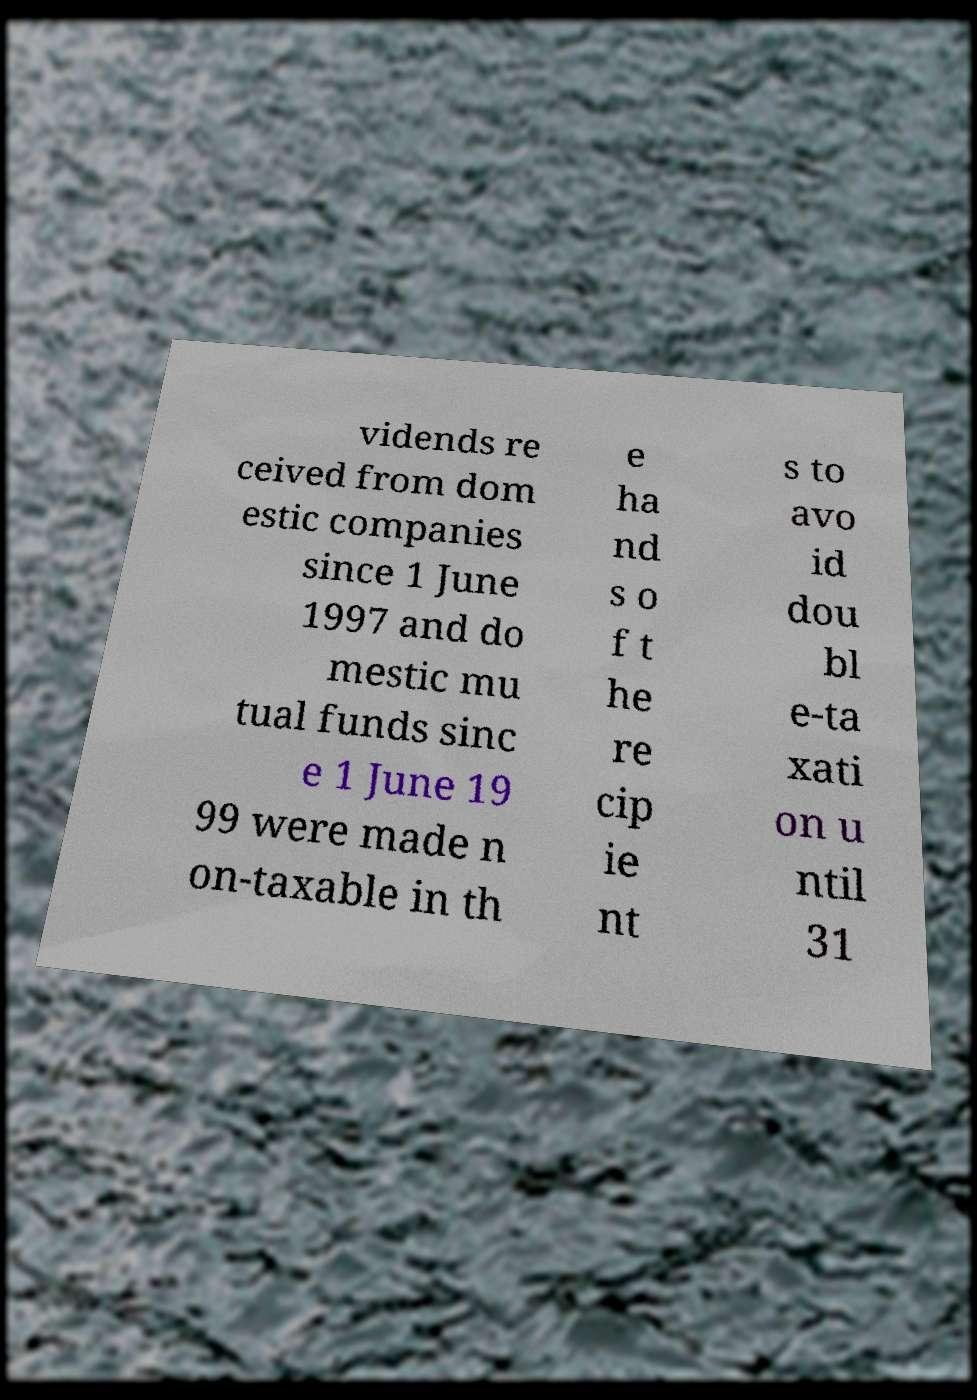I need the written content from this picture converted into text. Can you do that? vidends re ceived from dom estic companies since 1 June 1997 and do mestic mu tual funds sinc e 1 June 19 99 were made n on-taxable in th e ha nd s o f t he re cip ie nt s to avo id dou bl e-ta xati on u ntil 31 